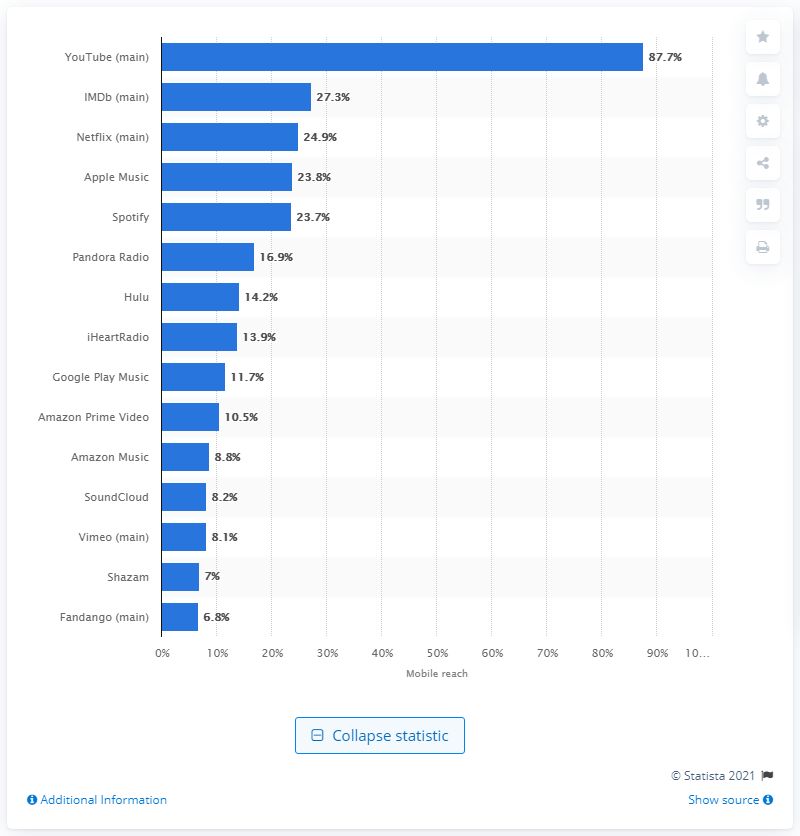Outline some significant characteristics in this image. According to data collected in September 2019, Spotify's reach among mobile audiences in the United States was 23.8%. 